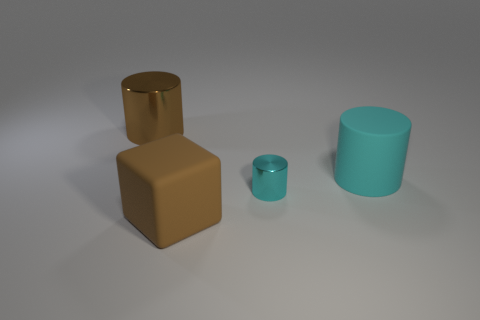The object that is the same color as the matte cylinder is what shape?
Ensure brevity in your answer.  Cylinder. How many cubes are on the left side of the big cyan rubber cylinder?
Provide a short and direct response. 1. What is the material of the thing that is both on the right side of the large rubber block and in front of the large matte cylinder?
Your response must be concise. Metal. How many blocks are small things or small purple things?
Provide a short and direct response. 0. There is another cyan object that is the same shape as the big cyan rubber thing; what material is it?
Offer a terse response. Metal. What size is the block that is the same material as the large cyan cylinder?
Make the answer very short. Large. There is a metallic thing to the right of the large brown shiny thing; does it have the same shape as the matte object that is behind the tiny shiny cylinder?
Provide a short and direct response. Yes. The thing that is the same material as the large cube is what color?
Your answer should be compact. Cyan. Is the size of the brown object in front of the brown cylinder the same as the shiny thing in front of the large brown cylinder?
Offer a very short reply. No. There is a object that is both behind the large brown rubber thing and to the left of the small cyan thing; what shape is it?
Provide a succinct answer. Cylinder. 